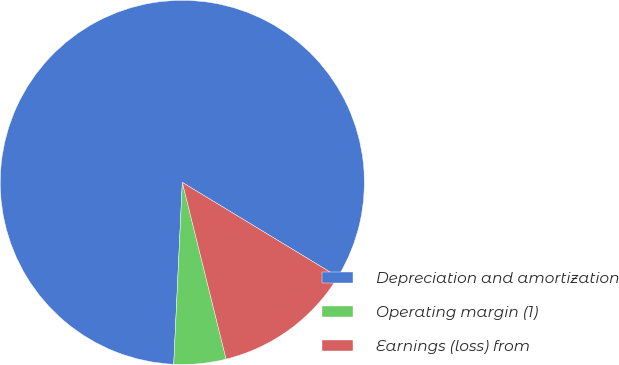<chart> <loc_0><loc_0><loc_500><loc_500><pie_chart><fcel>Depreciation and amortization<fcel>Operating margin (1)<fcel>Earnings (loss) from<nl><fcel>82.93%<fcel>4.62%<fcel>12.45%<nl></chart> 